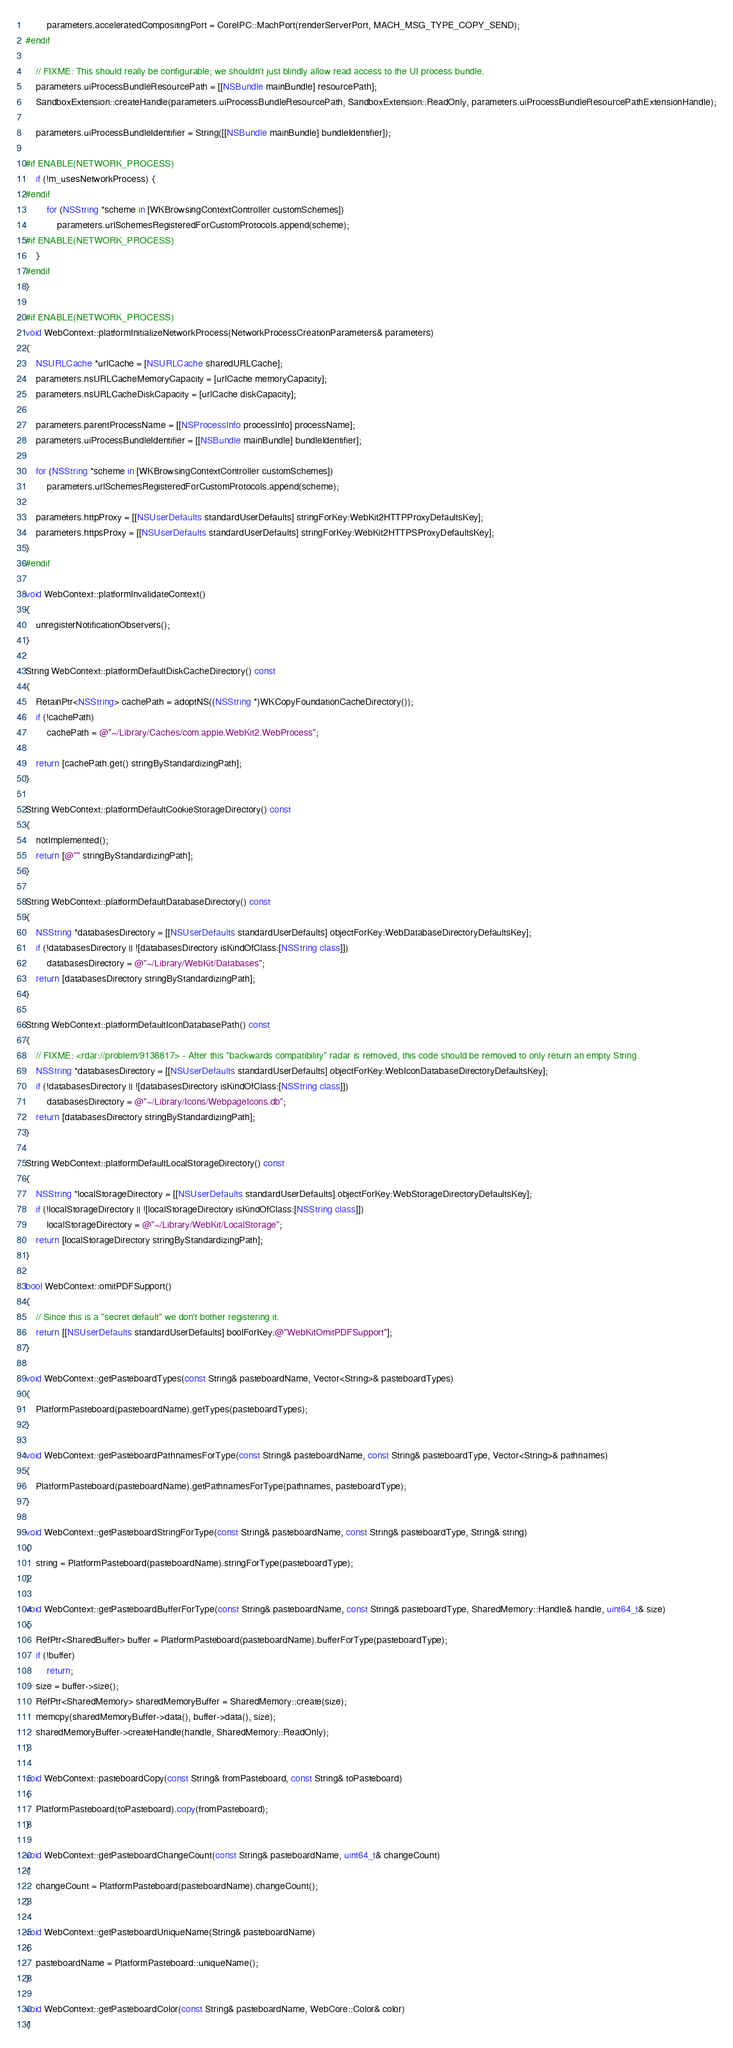Convert code to text. <code><loc_0><loc_0><loc_500><loc_500><_ObjectiveC_>        parameters.acceleratedCompositingPort = CoreIPC::MachPort(renderServerPort, MACH_MSG_TYPE_COPY_SEND);
#endif

    // FIXME: This should really be configurable; we shouldn't just blindly allow read access to the UI process bundle.
    parameters.uiProcessBundleResourcePath = [[NSBundle mainBundle] resourcePath];
    SandboxExtension::createHandle(parameters.uiProcessBundleResourcePath, SandboxExtension::ReadOnly, parameters.uiProcessBundleResourcePathExtensionHandle);

    parameters.uiProcessBundleIdentifier = String([[NSBundle mainBundle] bundleIdentifier]);

#if ENABLE(NETWORK_PROCESS)
    if (!m_usesNetworkProcess) {
#endif
        for (NSString *scheme in [WKBrowsingContextController customSchemes])
            parameters.urlSchemesRegisteredForCustomProtocols.append(scheme);
#if ENABLE(NETWORK_PROCESS)
    }
#endif
}

#if ENABLE(NETWORK_PROCESS)
void WebContext::platformInitializeNetworkProcess(NetworkProcessCreationParameters& parameters)
{
    NSURLCache *urlCache = [NSURLCache sharedURLCache];
    parameters.nsURLCacheMemoryCapacity = [urlCache memoryCapacity];
    parameters.nsURLCacheDiskCapacity = [urlCache diskCapacity];

    parameters.parentProcessName = [[NSProcessInfo processInfo] processName];
    parameters.uiProcessBundleIdentifier = [[NSBundle mainBundle] bundleIdentifier];

    for (NSString *scheme in [WKBrowsingContextController customSchemes])
        parameters.urlSchemesRegisteredForCustomProtocols.append(scheme);

    parameters.httpProxy = [[NSUserDefaults standardUserDefaults] stringForKey:WebKit2HTTPProxyDefaultsKey];
    parameters.httpsProxy = [[NSUserDefaults standardUserDefaults] stringForKey:WebKit2HTTPSProxyDefaultsKey];
}
#endif

void WebContext::platformInvalidateContext()
{
    unregisterNotificationObservers();
}

String WebContext::platformDefaultDiskCacheDirectory() const
{
    RetainPtr<NSString> cachePath = adoptNS((NSString *)WKCopyFoundationCacheDirectory());
    if (!cachePath)
        cachePath = @"~/Library/Caches/com.apple.WebKit2.WebProcess";

    return [cachePath.get() stringByStandardizingPath];
}

String WebContext::platformDefaultCookieStorageDirectory() const
{
    notImplemented();
    return [@"" stringByStandardizingPath];
}

String WebContext::platformDefaultDatabaseDirectory() const
{
    NSString *databasesDirectory = [[NSUserDefaults standardUserDefaults] objectForKey:WebDatabaseDirectoryDefaultsKey];
    if (!databasesDirectory || ![databasesDirectory isKindOfClass:[NSString class]])
        databasesDirectory = @"~/Library/WebKit/Databases";
    return [databasesDirectory stringByStandardizingPath];
}

String WebContext::platformDefaultIconDatabasePath() const
{
    // FIXME: <rdar://problem/9138817> - After this "backwards compatibility" radar is removed, this code should be removed to only return an empty String.
    NSString *databasesDirectory = [[NSUserDefaults standardUserDefaults] objectForKey:WebIconDatabaseDirectoryDefaultsKey];
    if (!databasesDirectory || ![databasesDirectory isKindOfClass:[NSString class]])
        databasesDirectory = @"~/Library/Icons/WebpageIcons.db";
    return [databasesDirectory stringByStandardizingPath];
}

String WebContext::platformDefaultLocalStorageDirectory() const
{
    NSString *localStorageDirectory = [[NSUserDefaults standardUserDefaults] objectForKey:WebStorageDirectoryDefaultsKey];
    if (!localStorageDirectory || ![localStorageDirectory isKindOfClass:[NSString class]])
        localStorageDirectory = @"~/Library/WebKit/LocalStorage";
    return [localStorageDirectory stringByStandardizingPath];
}

bool WebContext::omitPDFSupport()
{
    // Since this is a "secret default" we don't bother registering it.
    return [[NSUserDefaults standardUserDefaults] boolForKey:@"WebKitOmitPDFSupport"];
}

void WebContext::getPasteboardTypes(const String& pasteboardName, Vector<String>& pasteboardTypes)
{
    PlatformPasteboard(pasteboardName).getTypes(pasteboardTypes);
}

void WebContext::getPasteboardPathnamesForType(const String& pasteboardName, const String& pasteboardType, Vector<String>& pathnames)
{
    PlatformPasteboard(pasteboardName).getPathnamesForType(pathnames, pasteboardType);
}

void WebContext::getPasteboardStringForType(const String& pasteboardName, const String& pasteboardType, String& string)
{
    string = PlatformPasteboard(pasteboardName).stringForType(pasteboardType);
}

void WebContext::getPasteboardBufferForType(const String& pasteboardName, const String& pasteboardType, SharedMemory::Handle& handle, uint64_t& size)
{
    RefPtr<SharedBuffer> buffer = PlatformPasteboard(pasteboardName).bufferForType(pasteboardType);
    if (!buffer)
        return;
    size = buffer->size();
    RefPtr<SharedMemory> sharedMemoryBuffer = SharedMemory::create(size);
    memcpy(sharedMemoryBuffer->data(), buffer->data(), size);
    sharedMemoryBuffer->createHandle(handle, SharedMemory::ReadOnly);
}

void WebContext::pasteboardCopy(const String& fromPasteboard, const String& toPasteboard)
{
    PlatformPasteboard(toPasteboard).copy(fromPasteboard);
}

void WebContext::getPasteboardChangeCount(const String& pasteboardName, uint64_t& changeCount)
{
    changeCount = PlatformPasteboard(pasteboardName).changeCount();
}

void WebContext::getPasteboardUniqueName(String& pasteboardName)
{
    pasteboardName = PlatformPasteboard::uniqueName();
}

void WebContext::getPasteboardColor(const String& pasteboardName, WebCore::Color& color)
{</code> 